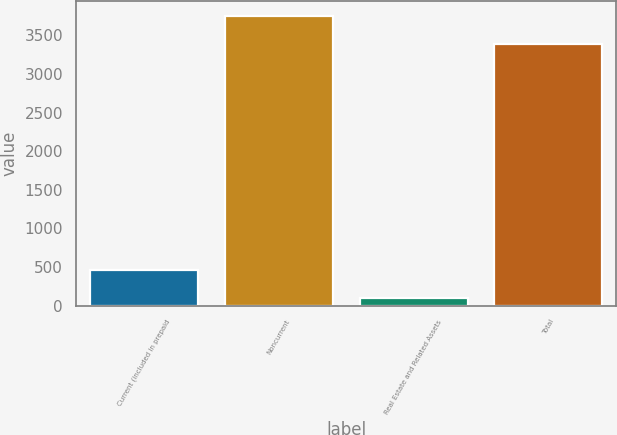Convert chart. <chart><loc_0><loc_0><loc_500><loc_500><bar_chart><fcel>Current (included in prepaid<fcel>Noncurrent<fcel>Real Estate and Related Assets<fcel>Total<nl><fcel>457.3<fcel>3753.3<fcel>98<fcel>3394<nl></chart> 